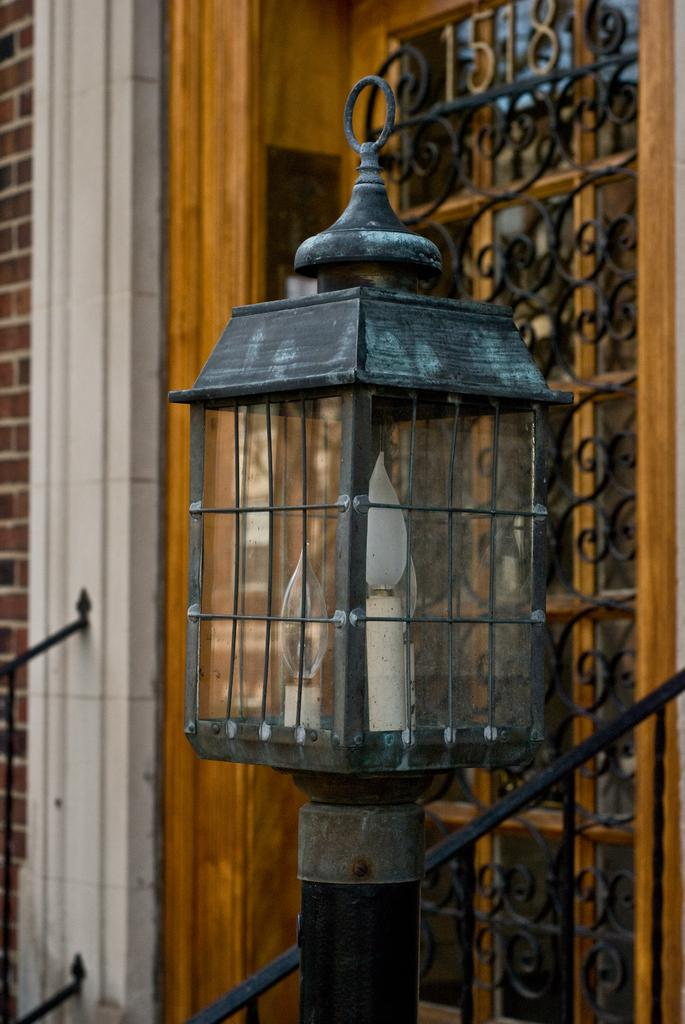What is the main object in the foreground of the image? There is a decorative light pole in the foreground of the image. What type of material is the fence in the image made of? The fence in the image is made of metal. What can be seen on the left side of the image? There are bricks on the left side of the image. How many pigs are visible in the image? There are no pigs present in the image. What emotion is being expressed by the fireman in the image? There is no fireman present in the image, so it is not possible to determine any emotions being expressed. 